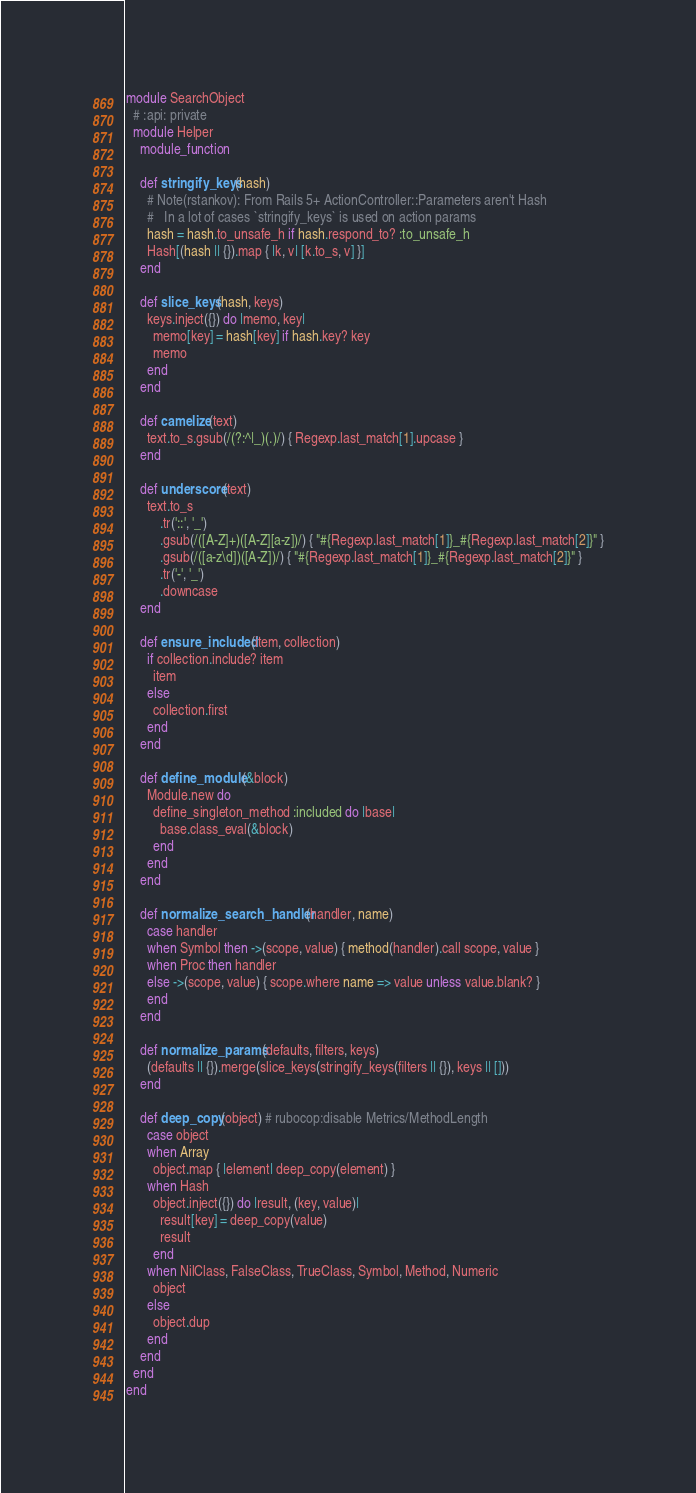<code> <loc_0><loc_0><loc_500><loc_500><_Ruby_>module SearchObject
  # :api: private
  module Helper
    module_function

    def stringify_keys(hash)
      # Note(rstankov): From Rails 5+ ActionController::Parameters aren't Hash
      #   In a lot of cases `stringify_keys` is used on action params
      hash = hash.to_unsafe_h if hash.respond_to? :to_unsafe_h
      Hash[(hash || {}).map { |k, v| [k.to_s, v] }]
    end

    def slice_keys(hash, keys)
      keys.inject({}) do |memo, key|
        memo[key] = hash[key] if hash.key? key
        memo
      end
    end

    def camelize(text)
      text.to_s.gsub(/(?:^|_)(.)/) { Regexp.last_match[1].upcase }
    end

    def underscore(text)
      text.to_s
          .tr('::', '_')
          .gsub(/([A-Z]+)([A-Z][a-z])/) { "#{Regexp.last_match[1]}_#{Regexp.last_match[2]}" }
          .gsub(/([a-z\d])([A-Z])/) { "#{Regexp.last_match[1]}_#{Regexp.last_match[2]}" }
          .tr('-', '_')
          .downcase
    end

    def ensure_included(item, collection)
      if collection.include? item
        item
      else
        collection.first
      end
    end

    def define_module(&block)
      Module.new do
        define_singleton_method :included do |base|
          base.class_eval(&block)
        end
      end
    end

    def normalize_search_handler(handler, name)
      case handler
      when Symbol then ->(scope, value) { method(handler).call scope, value }
      when Proc then handler
      else ->(scope, value) { scope.where name => value unless value.blank? }
      end
    end

    def normalize_params(defaults, filters, keys)
      (defaults || {}).merge(slice_keys(stringify_keys(filters || {}), keys || []))
    end

    def deep_copy(object) # rubocop:disable Metrics/MethodLength
      case object
      when Array
        object.map { |element| deep_copy(element) }
      when Hash
        object.inject({}) do |result, (key, value)|
          result[key] = deep_copy(value)
          result
        end
      when NilClass, FalseClass, TrueClass, Symbol, Method, Numeric
        object
      else
        object.dup
      end
    end
  end
end
</code> 